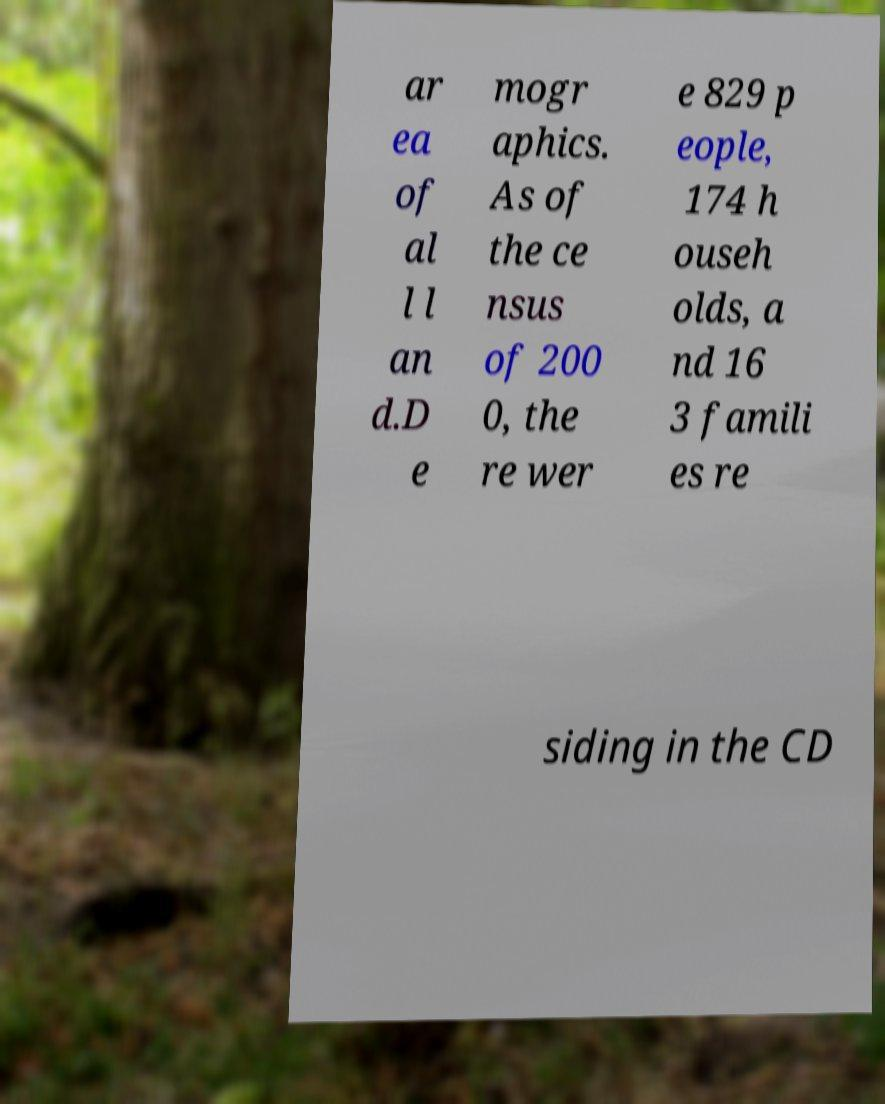Please read and relay the text visible in this image. What does it say? ar ea of al l l an d.D e mogr aphics. As of the ce nsus of 200 0, the re wer e 829 p eople, 174 h ouseh olds, a nd 16 3 famili es re siding in the CD 